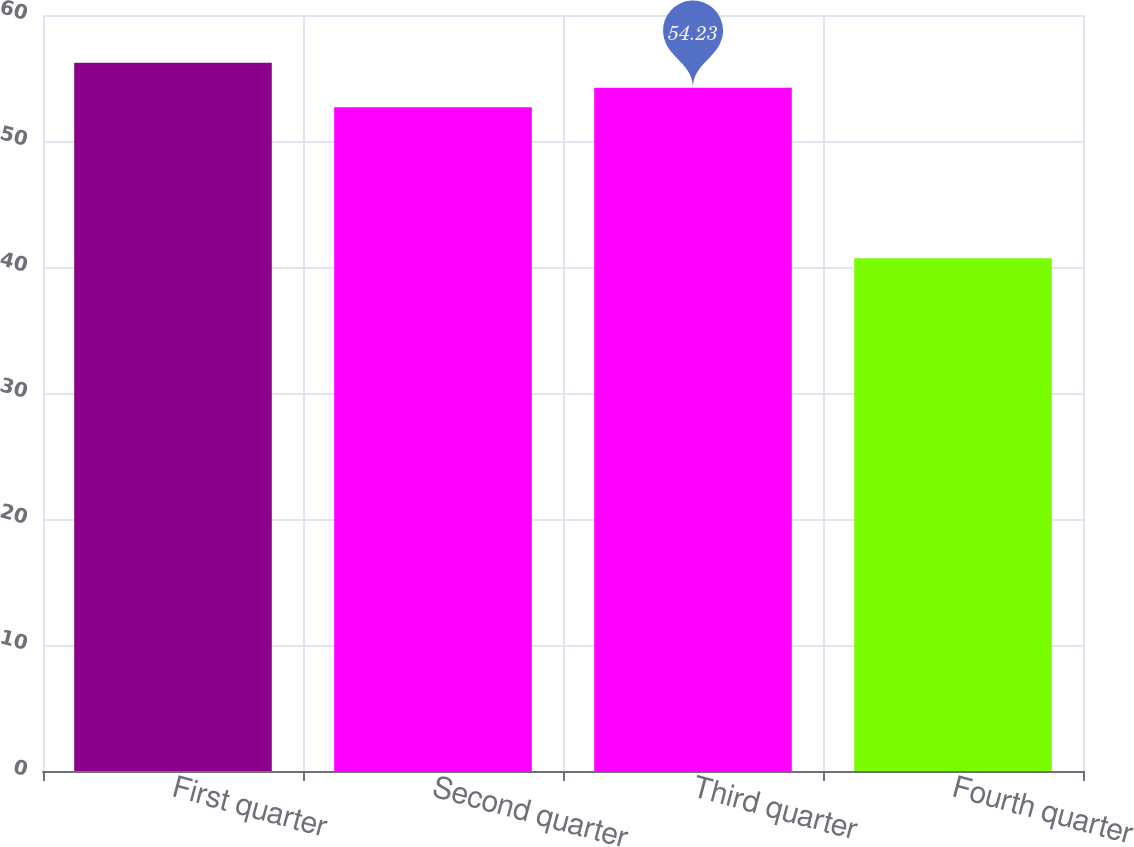Convert chart to OTSL. <chart><loc_0><loc_0><loc_500><loc_500><bar_chart><fcel>First quarter<fcel>Second quarter<fcel>Third quarter<fcel>Fourth quarter<nl><fcel>56.22<fcel>52.68<fcel>54.23<fcel>40.7<nl></chart> 